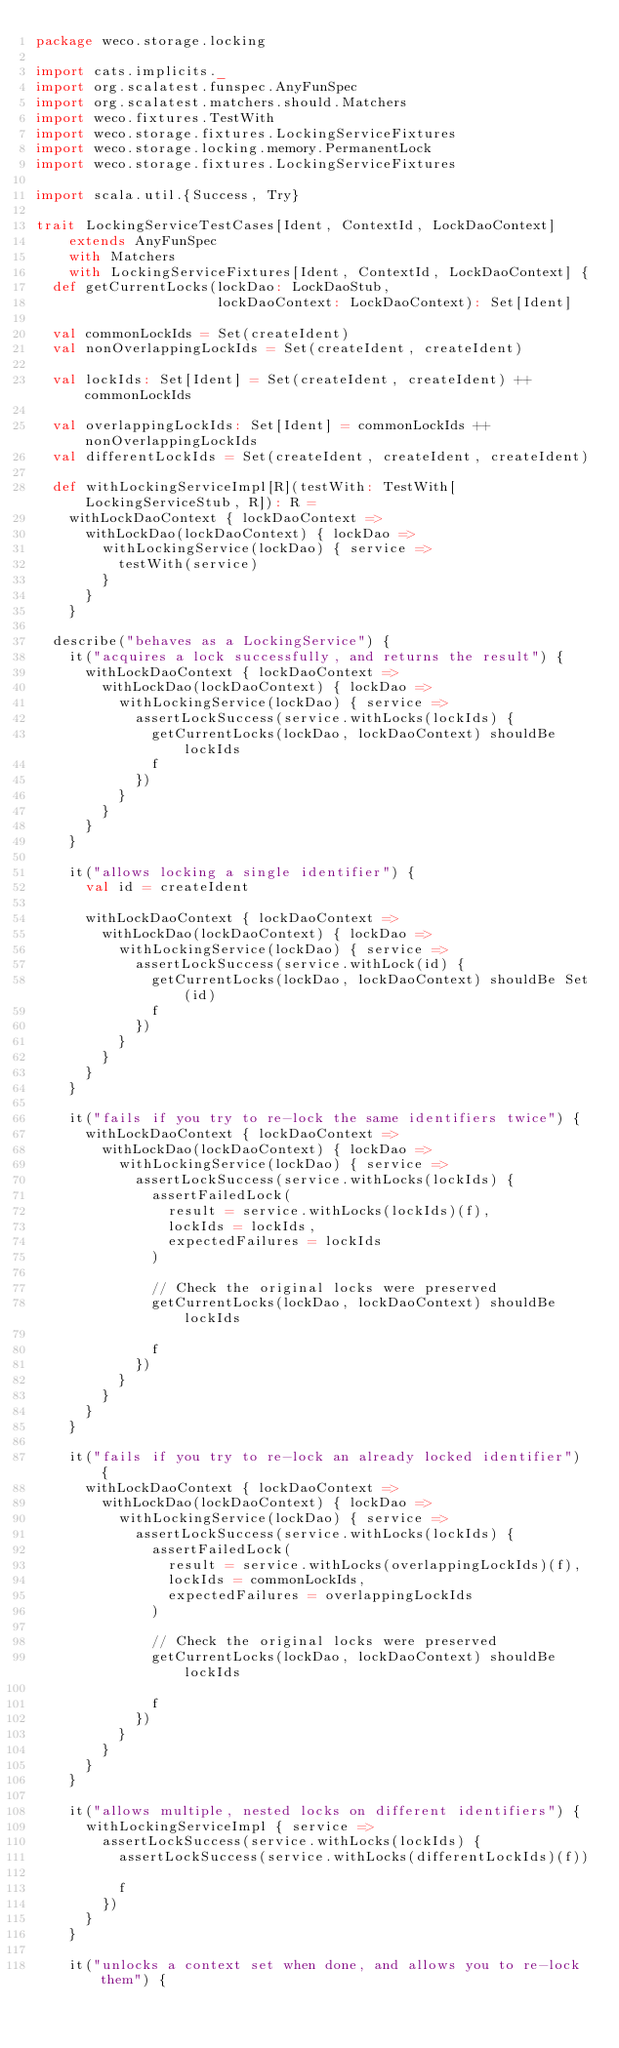<code> <loc_0><loc_0><loc_500><loc_500><_Scala_>package weco.storage.locking

import cats.implicits._
import org.scalatest.funspec.AnyFunSpec
import org.scalatest.matchers.should.Matchers
import weco.fixtures.TestWith
import weco.storage.fixtures.LockingServiceFixtures
import weco.storage.locking.memory.PermanentLock
import weco.storage.fixtures.LockingServiceFixtures

import scala.util.{Success, Try}

trait LockingServiceTestCases[Ident, ContextId, LockDaoContext]
    extends AnyFunSpec
    with Matchers
    with LockingServiceFixtures[Ident, ContextId, LockDaoContext] {
  def getCurrentLocks(lockDao: LockDaoStub,
                      lockDaoContext: LockDaoContext): Set[Ident]

  val commonLockIds = Set(createIdent)
  val nonOverlappingLockIds = Set(createIdent, createIdent)

  val lockIds: Set[Ident] = Set(createIdent, createIdent) ++ commonLockIds

  val overlappingLockIds: Set[Ident] = commonLockIds ++ nonOverlappingLockIds
  val differentLockIds = Set(createIdent, createIdent, createIdent)

  def withLockingServiceImpl[R](testWith: TestWith[LockingServiceStub, R]): R =
    withLockDaoContext { lockDaoContext =>
      withLockDao(lockDaoContext) { lockDao =>
        withLockingService(lockDao) { service =>
          testWith(service)
        }
      }
    }

  describe("behaves as a LockingService") {
    it("acquires a lock successfully, and returns the result") {
      withLockDaoContext { lockDaoContext =>
        withLockDao(lockDaoContext) { lockDao =>
          withLockingService(lockDao) { service =>
            assertLockSuccess(service.withLocks(lockIds) {
              getCurrentLocks(lockDao, lockDaoContext) shouldBe lockIds
              f
            })
          }
        }
      }
    }

    it("allows locking a single identifier") {
      val id = createIdent

      withLockDaoContext { lockDaoContext =>
        withLockDao(lockDaoContext) { lockDao =>
          withLockingService(lockDao) { service =>
            assertLockSuccess(service.withLock(id) {
              getCurrentLocks(lockDao, lockDaoContext) shouldBe Set(id)
              f
            })
          }
        }
      }
    }

    it("fails if you try to re-lock the same identifiers twice") {
      withLockDaoContext { lockDaoContext =>
        withLockDao(lockDaoContext) { lockDao =>
          withLockingService(lockDao) { service =>
            assertLockSuccess(service.withLocks(lockIds) {
              assertFailedLock(
                result = service.withLocks(lockIds)(f),
                lockIds = lockIds,
                expectedFailures = lockIds
              )

              // Check the original locks were preserved
              getCurrentLocks(lockDao, lockDaoContext) shouldBe lockIds

              f
            })
          }
        }
      }
    }

    it("fails if you try to re-lock an already locked identifier") {
      withLockDaoContext { lockDaoContext =>
        withLockDao(lockDaoContext) { lockDao =>
          withLockingService(lockDao) { service =>
            assertLockSuccess(service.withLocks(lockIds) {
              assertFailedLock(
                result = service.withLocks(overlappingLockIds)(f),
                lockIds = commonLockIds,
                expectedFailures = overlappingLockIds
              )

              // Check the original locks were preserved
              getCurrentLocks(lockDao, lockDaoContext) shouldBe lockIds

              f
            })
          }
        }
      }
    }

    it("allows multiple, nested locks on different identifiers") {
      withLockingServiceImpl { service =>
        assertLockSuccess(service.withLocks(lockIds) {
          assertLockSuccess(service.withLocks(differentLockIds)(f))

          f
        })
      }
    }

    it("unlocks a context set when done, and allows you to re-lock them") {</code> 